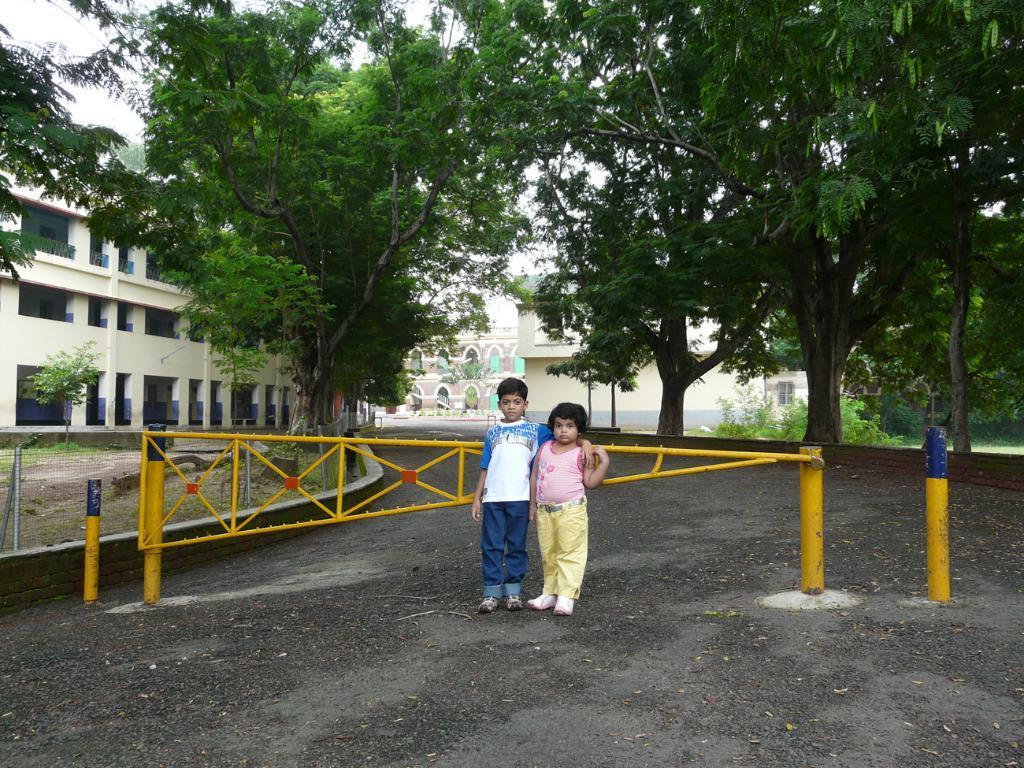Describe this image in one or two sentences. There are two children in different color dresses standing on the road near a yellow color gate. In the background, there are trees, buildings, a fencing and there is sky. 